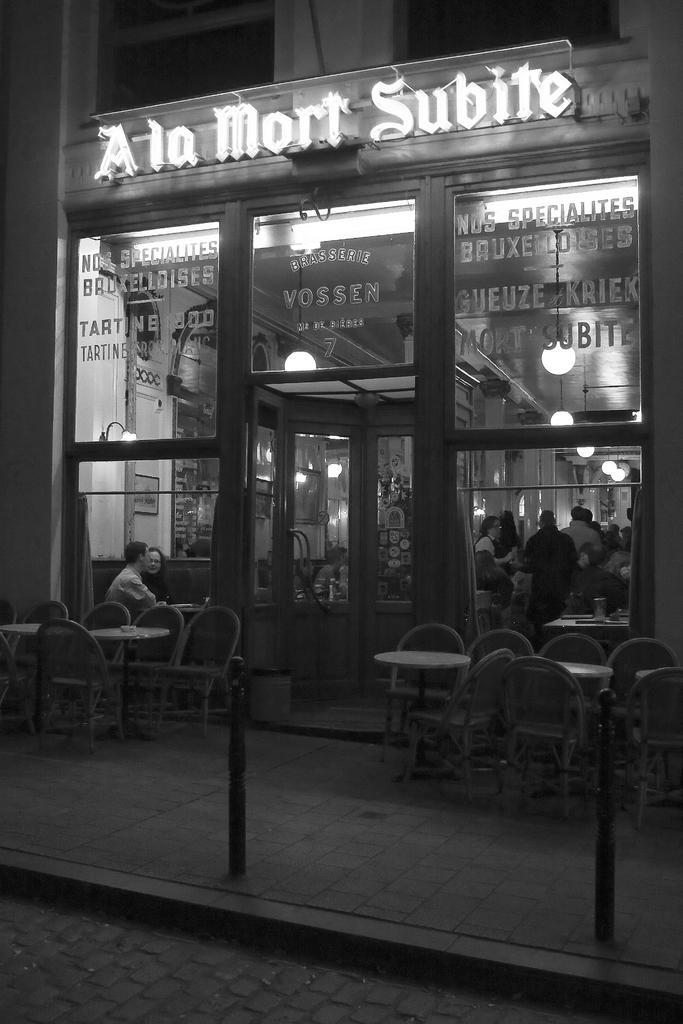How would you summarize this image in a sentence or two? This is is a black and white picture. This is a store. here we can see few persons in a store. These are tables and chairs. This is a road. 